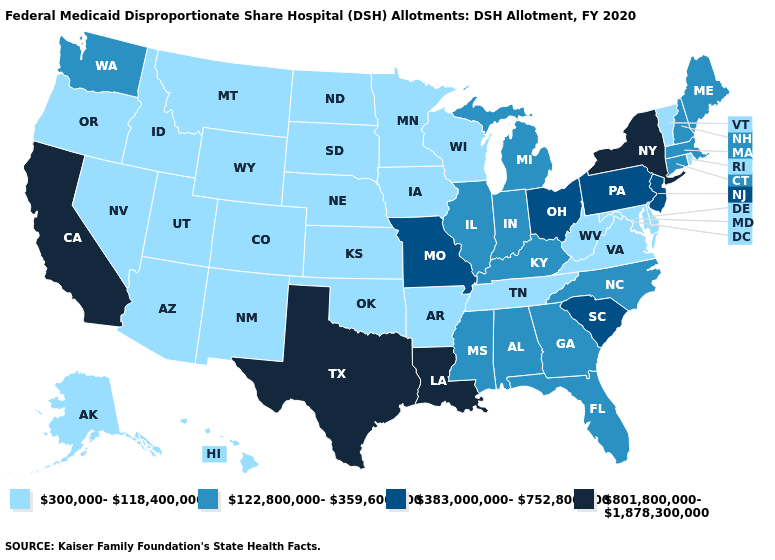Name the states that have a value in the range 122,800,000-359,600,000?
Concise answer only. Alabama, Connecticut, Florida, Georgia, Illinois, Indiana, Kentucky, Maine, Massachusetts, Michigan, Mississippi, New Hampshire, North Carolina, Washington. Name the states that have a value in the range 122,800,000-359,600,000?
Keep it brief. Alabama, Connecticut, Florida, Georgia, Illinois, Indiana, Kentucky, Maine, Massachusetts, Michigan, Mississippi, New Hampshire, North Carolina, Washington. Is the legend a continuous bar?
Answer briefly. No. Name the states that have a value in the range 122,800,000-359,600,000?
Quick response, please. Alabama, Connecticut, Florida, Georgia, Illinois, Indiana, Kentucky, Maine, Massachusetts, Michigan, Mississippi, New Hampshire, North Carolina, Washington. Name the states that have a value in the range 383,000,000-752,800,000?
Short answer required. Missouri, New Jersey, Ohio, Pennsylvania, South Carolina. Does Mississippi have the lowest value in the USA?
Keep it brief. No. Name the states that have a value in the range 122,800,000-359,600,000?
Be succinct. Alabama, Connecticut, Florida, Georgia, Illinois, Indiana, Kentucky, Maine, Massachusetts, Michigan, Mississippi, New Hampshire, North Carolina, Washington. Name the states that have a value in the range 122,800,000-359,600,000?
Be succinct. Alabama, Connecticut, Florida, Georgia, Illinois, Indiana, Kentucky, Maine, Massachusetts, Michigan, Mississippi, New Hampshire, North Carolina, Washington. What is the highest value in the USA?
Short answer required. 801,800,000-1,878,300,000. What is the value of West Virginia?
Be succinct. 300,000-118,400,000. Which states have the lowest value in the USA?
Answer briefly. Alaska, Arizona, Arkansas, Colorado, Delaware, Hawaii, Idaho, Iowa, Kansas, Maryland, Minnesota, Montana, Nebraska, Nevada, New Mexico, North Dakota, Oklahoma, Oregon, Rhode Island, South Dakota, Tennessee, Utah, Vermont, Virginia, West Virginia, Wisconsin, Wyoming. What is the value of Louisiana?
Short answer required. 801,800,000-1,878,300,000. What is the value of New Hampshire?
Concise answer only. 122,800,000-359,600,000. What is the value of Louisiana?
Be succinct. 801,800,000-1,878,300,000. 